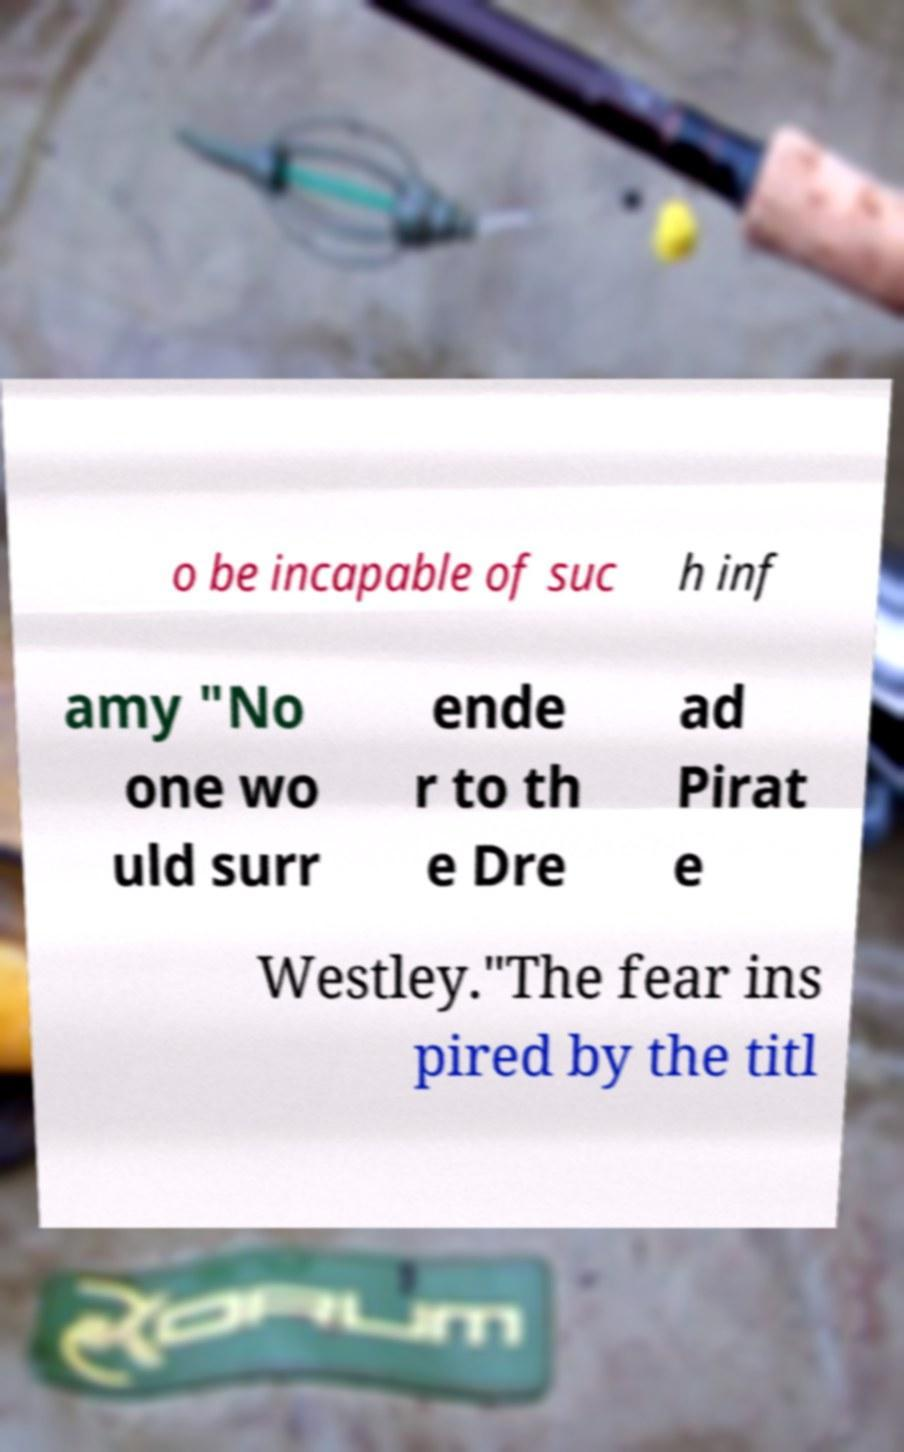I need the written content from this picture converted into text. Can you do that? o be incapable of suc h inf amy "No one wo uld surr ende r to th e Dre ad Pirat e Westley."The fear ins pired by the titl 